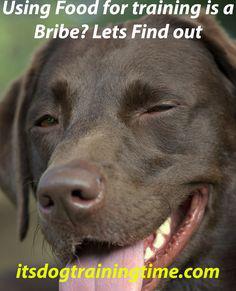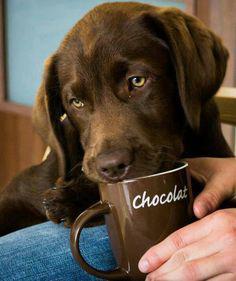The first image is the image on the left, the second image is the image on the right. Analyze the images presented: Is the assertion "Both images are a head shot of one dog with its mouth closed." valid? Answer yes or no. No. The first image is the image on the left, the second image is the image on the right. Analyze the images presented: Is the assertion "One of the images shows a dog with its tongue sticking out." valid? Answer yes or no. Yes. 